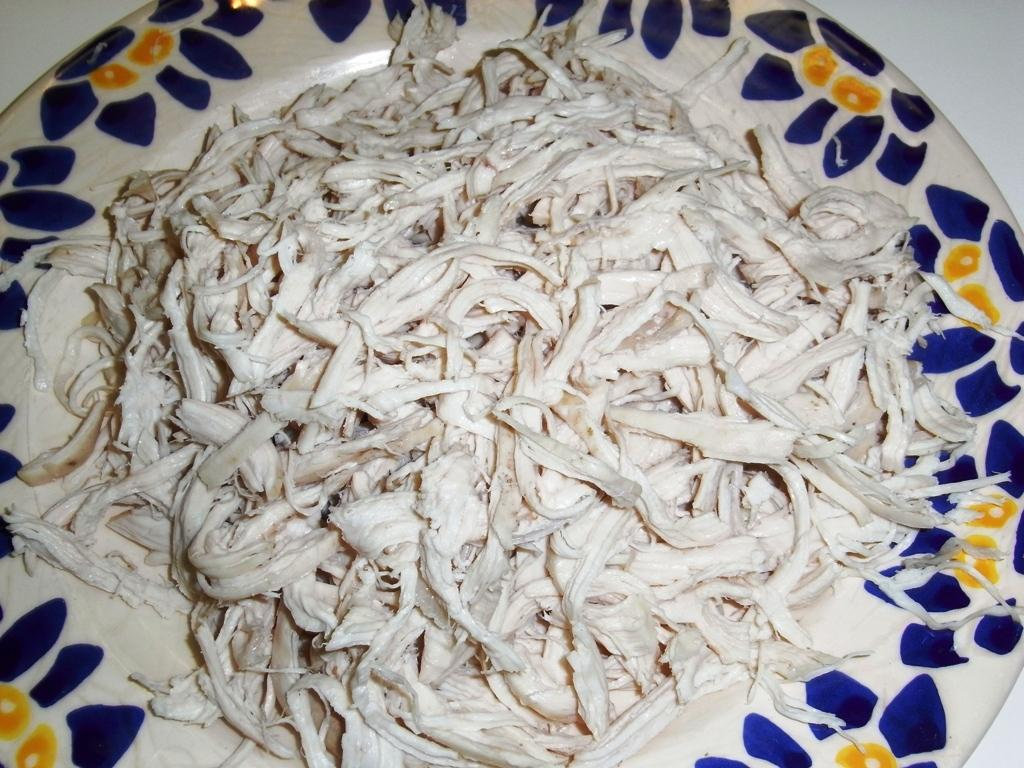What is present on the plate in the image? The plate has white, blue, and yellow colors, and there are white color things on the plate. Can you describe the colors of the plate in the image? The plate has white, blue, and yellow colors. What color is the surface in the image? There is a white color surface in the image. How do the hands interact with the plate in the image? There are no hands present in the image, so it is not possible to describe any interaction with the plate. 